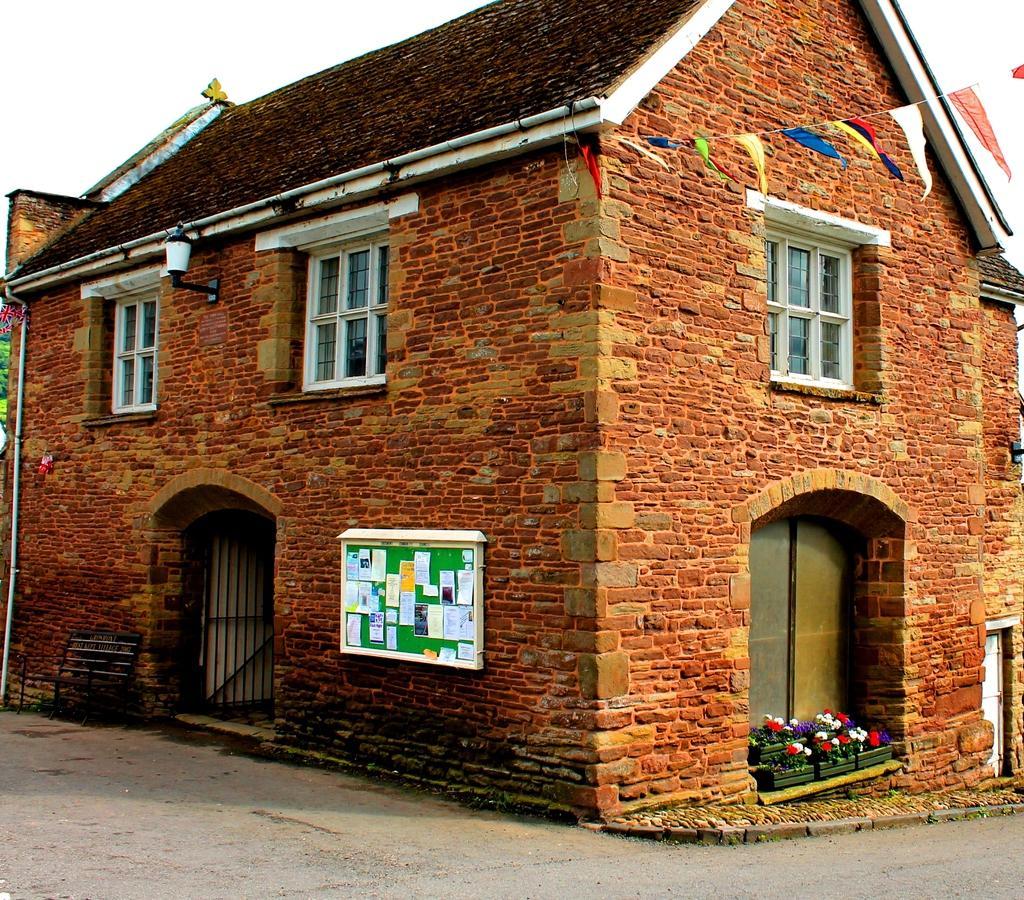In one or two sentences, can you explain what this image depicts? In the center of the image there is a house. At the bottom of the image there is road. At the top of the image there is sky. There are windows. 